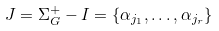<formula> <loc_0><loc_0><loc_500><loc_500>J = \Sigma _ { G } ^ { + } - I = \{ \alpha _ { j _ { 1 } } , \dots , \alpha _ { j _ { r } } \}</formula> 